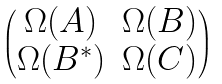<formula> <loc_0><loc_0><loc_500><loc_500>\begin{pmatrix} \Omega ( A ) & \Omega ( B ) \\ \Omega ( B ^ { \ast } ) & \Omega ( C ) \end{pmatrix}</formula> 